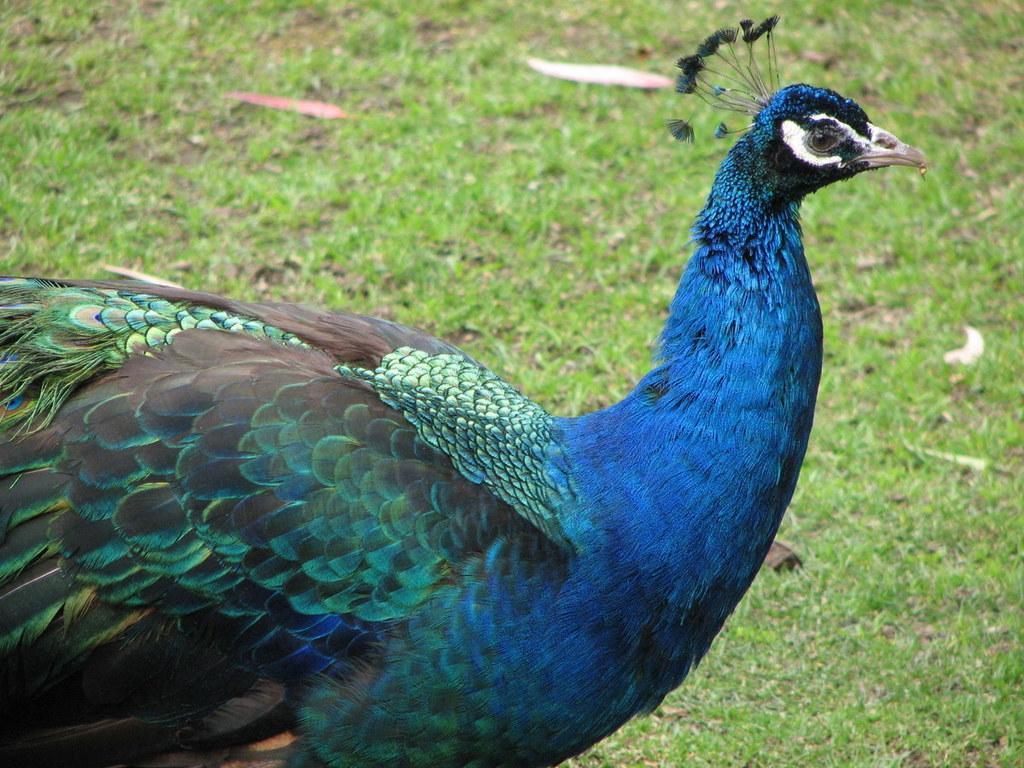Can you describe this image briefly? In this image, we can see a peacock. In the background, we can see a grass. 